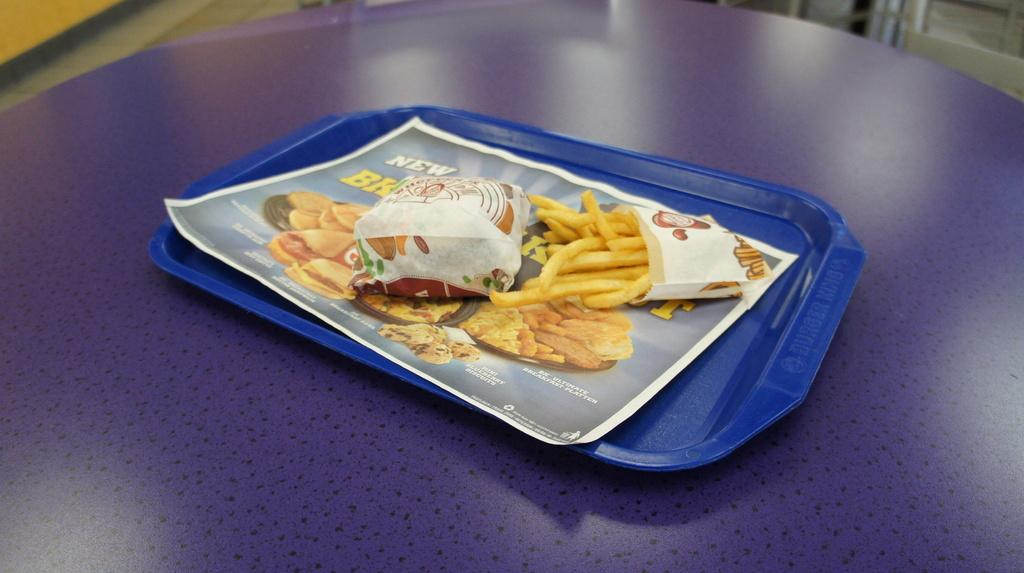What type of furniture is present in the image? There is a table in the image. What is on the table in the image? There is a plate with food on the table. What can be seen on the wall in the image? There is a poster with text and images in the image. Is there a fight happening between the food and the poster in the image? No, there is no fight happening between the food and the poster in the image. Can you compare the size of the plate with the size of the poster in the image? It is not possible to compare the size of the plate with the size of the poster in the image, as the provided facts do not include any information about their sizes. 